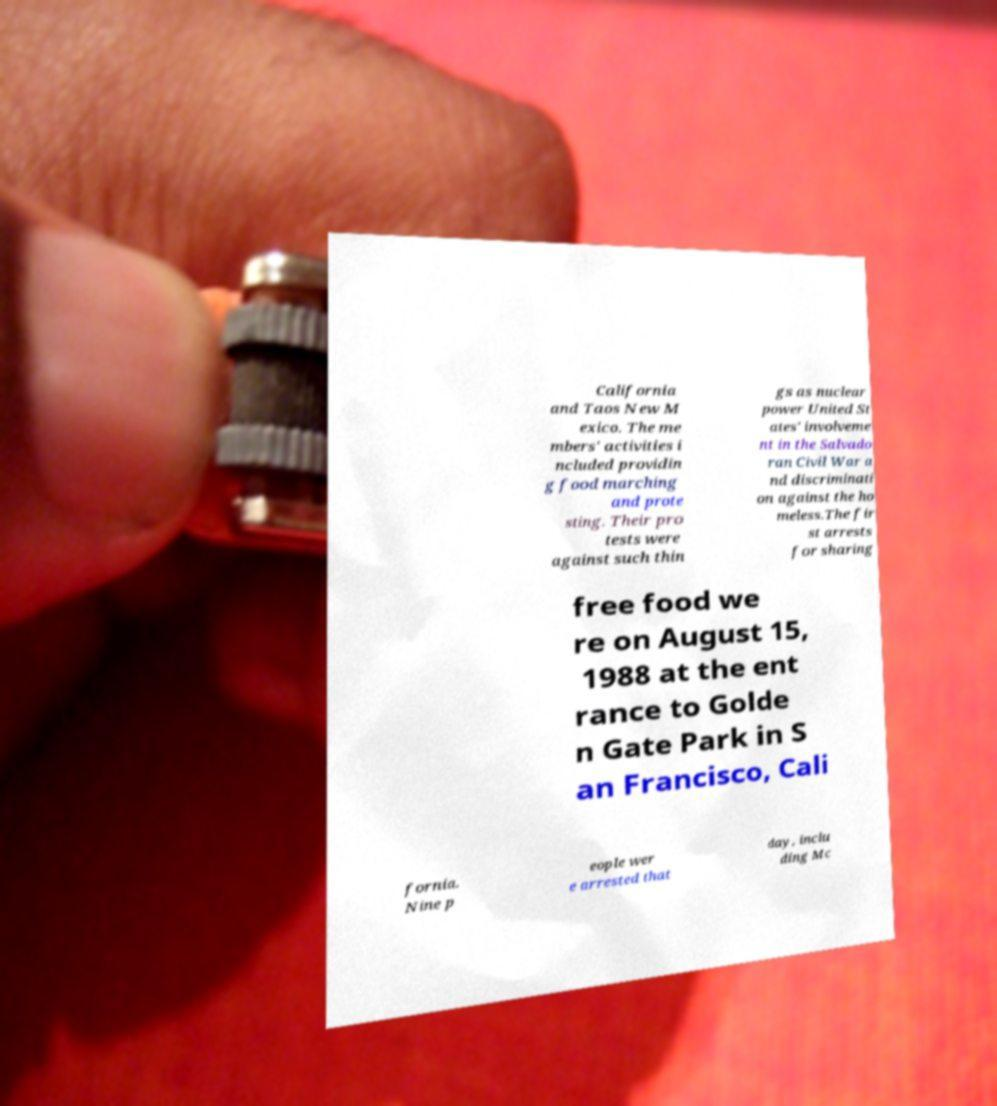What messages or text are displayed in this image? I need them in a readable, typed format. California and Taos New M exico. The me mbers' activities i ncluded providin g food marching and prote sting. Their pro tests were against such thin gs as nuclear power United St ates' involveme nt in the Salvado ran Civil War a nd discriminati on against the ho meless.The fir st arrests for sharing free food we re on August 15, 1988 at the ent rance to Golde n Gate Park in S an Francisco, Cali fornia. Nine p eople wer e arrested that day, inclu ding Mc 